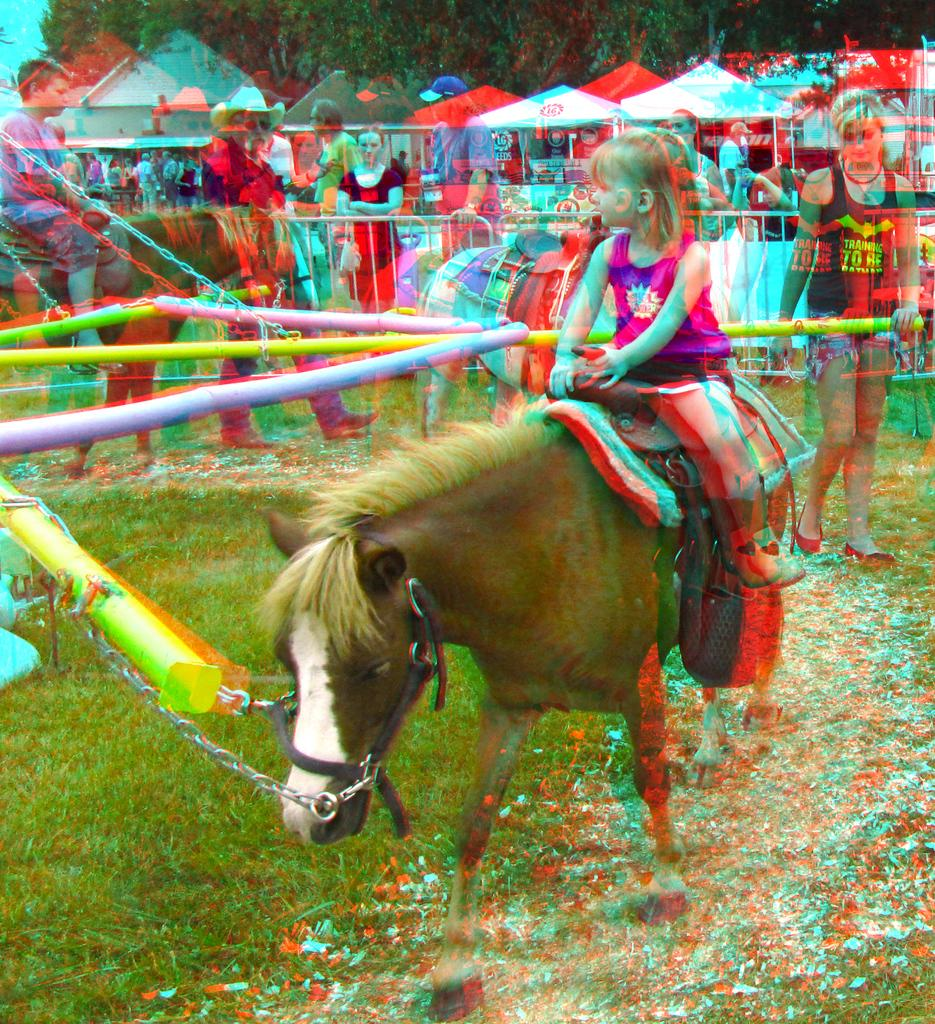What is the girl in the image doing? The girl is sitting on a horse in the image. What type of terrain is visible in the image? There is grass in the image. What can be seen in the background of the image? There is a group of people standing in the background. What type of shelter is present in the image? There is a tent in the image. What type of vegetation is visible in the image? There are trees in the image. What type of shape is the judge holding in the image? There is no judge present in the image, and therefore no shape can be held by a judge. 